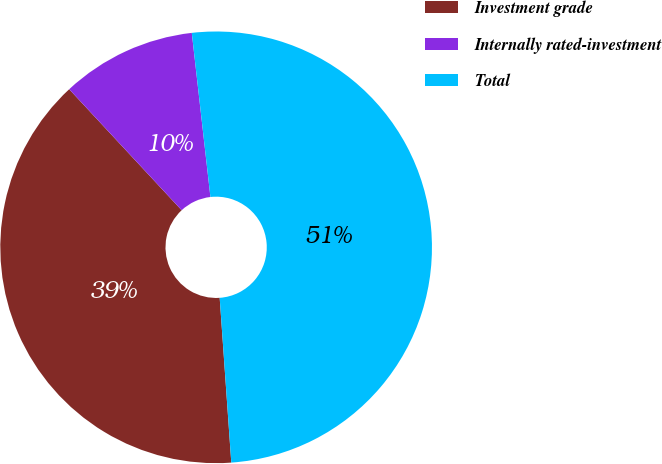Convert chart to OTSL. <chart><loc_0><loc_0><loc_500><loc_500><pie_chart><fcel>Investment grade<fcel>Internally rated-investment<fcel>Total<nl><fcel>39.2%<fcel>10.12%<fcel>50.68%<nl></chart> 